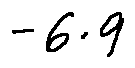Convert formula to latex. <formula><loc_0><loc_0><loc_500><loc_500>- 6 . 9</formula> 